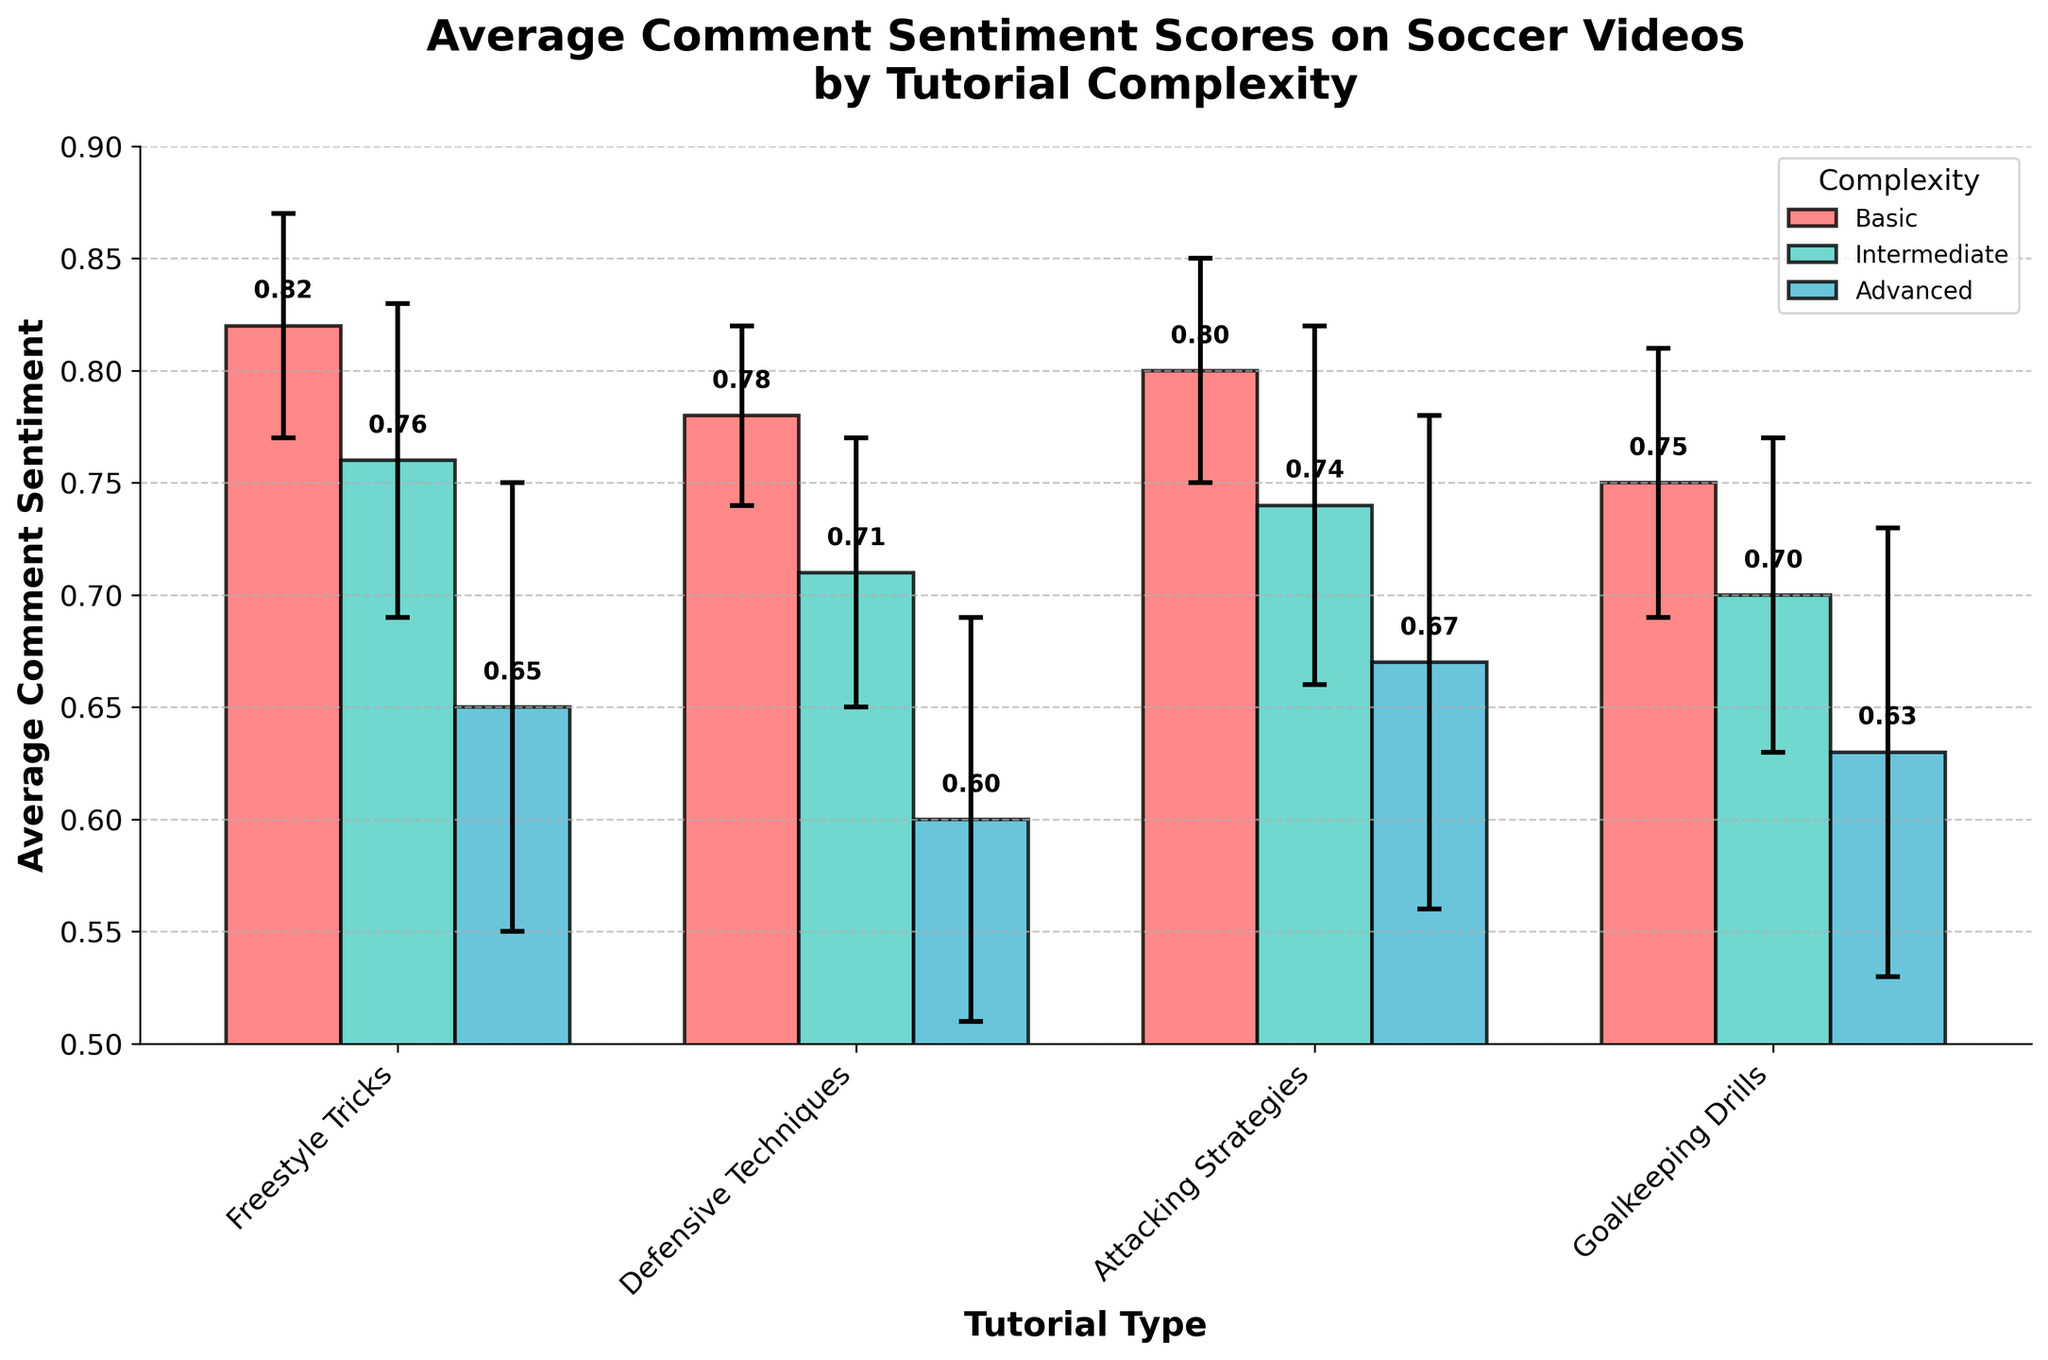What is the average comment sentiment score for basic complexity Attacking Strategies tutorials? Locate the bar corresponding to Attacking Strategies with basic complexity. The bar height represents the average sentiment score, which is 0.80.
Answer: 0.80 What is the title of the plot? The plot title is positioned at the top and reads: "Average Comment Sentiment Scores on Soccer Videos by Tutorial Complexity".
Answer: Average Comment Sentiment Scores on Soccer Videos by Tutorial Complexity How many different tutorial complexities are shown in the plot? The legend labels indicate that there are three different complexities: Basic, Intermediate, and Advanced.
Answer: 3 Which tutorial type has the lowest average sentiment score for advanced complexity tutorials? By looking at the bars for the advanced complexity across all tutorial types, Defensive Techniques has the lowest sentiment score of 0.60.
Answer: Defensive Techniques Between basic and advanced Freestyle Tricks tutorials, which one has a higher average sentiment score and by how much? The bar heights for Freestyle Tricks with basic and advanced complexities are 0.82 and 0.65, respectively. The difference is 0.82 - 0.65 = 0.17.
Answer: Basic by 0.17 What is the average comment sentiment score for intermediate complexity Goalkeeping Drills tutorials? Locate the bar corresponding to Goalkeeping Drills with intermediate complexity. The bar height represents the average sentiment score, which is 0.70.
Answer: 0.70 Which complexity level has the overall highest average sentiment score across all tutorial types? Compare the highest bars for each complexity level. The highest bar overall is for Freestyle Tricks at basic complexity, with a score of 0.82.
Answer: Basic What is the difference in average comment sentiment scores between basic and intermediate Defensive Techniques tutorials? The bar heights for Defensive Techniques with basic and intermediate complexities are 0.78 and 0.71, respectively. The difference is 0.78 - 0.71 = 0.07.
Answer: 0.07 How do the error bars for advanced complexity tutorials compare to other complexities? Error bars for advanced complexity are generally larger compared to basic and intermediate complexity bars, indicating higher variability in sentiment scores.
Answer: Larger 